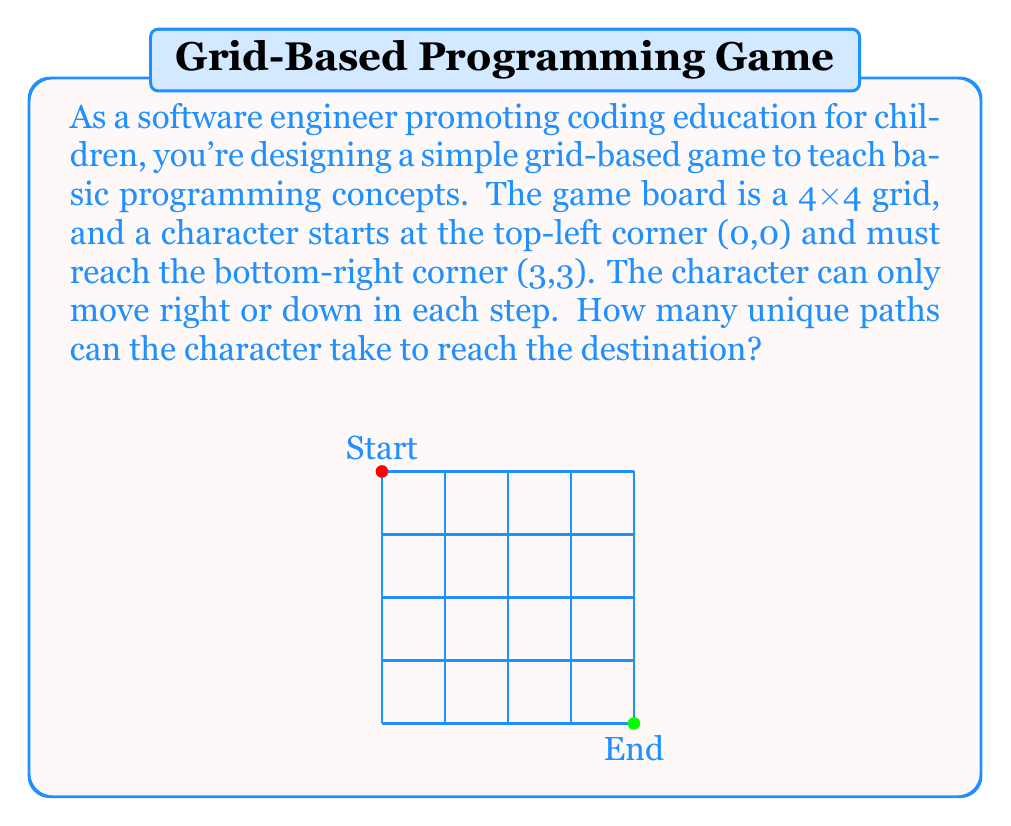Solve this math problem. Let's approach this step-by-step:

1) First, observe that to reach the bottom-right corner from the top-left, the character must always move 3 steps right and 3 steps down, regardless of the path taken.

2) This problem is equivalent to choosing when to make the 3 right moves out of the total 6 moves (as the other 3 will be down moves).

3) Mathematically, this is a combination problem. We need to calculate "6 choose 3" or $\binom{6}{3}$.

4) The formula for this combination is:

   $$\binom{6}{3} = \frac{6!}{3!(6-3)!} = \frac{6!}{3!3!}$$

5) Let's calculate this:
   
   $$\frac{6 \times 5 \times 4 \times 3!}{3 \times 2 \times 1 \times 3!} = \frac{6 \times 5 \times 4}{3 \times 2 \times 1} = \frac{120}{6} = 20$$

6) Therefore, there are 20 unique paths from the start to the end.

This problem introduces children to the concept of combinatorics, which is fundamental in many areas of computer science, including algorithm analysis and data structures.
Answer: 20 unique paths 